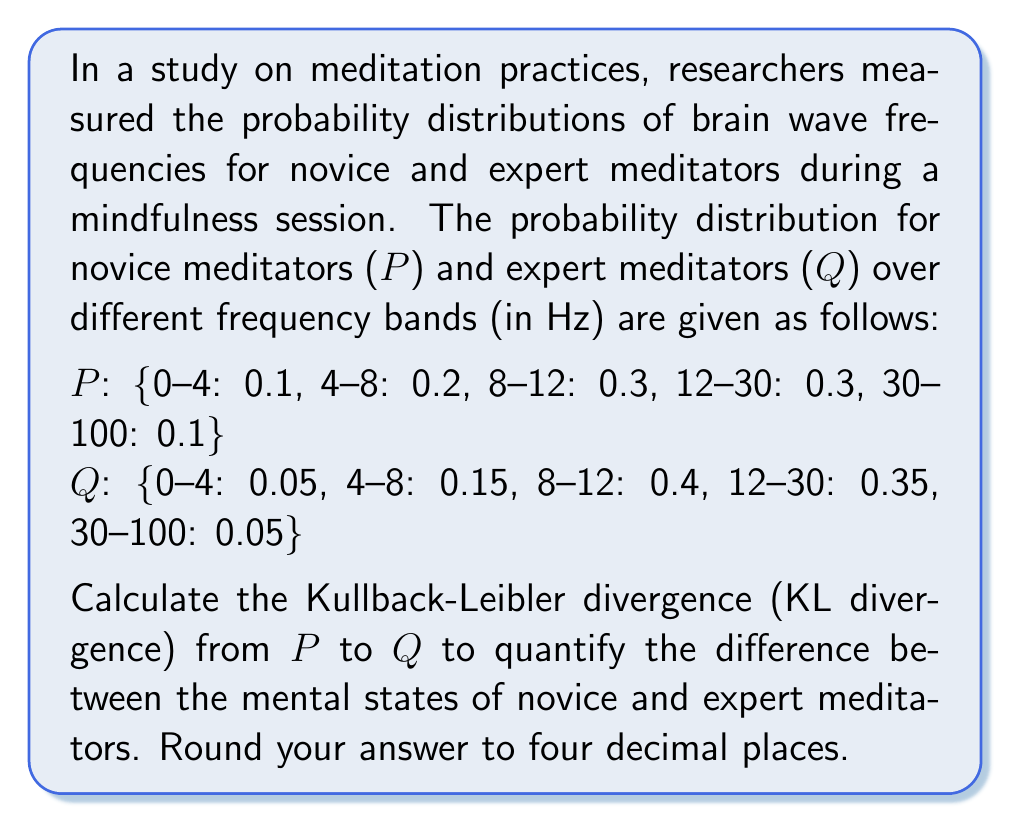Provide a solution to this math problem. To solve this problem, we'll use the Kullback-Leibler divergence formula:

$$ D_{KL}(P||Q) = \sum_{i} P(i) \log\left(\frac{P(i)}{Q(i)}\right) $$

Where P(i) and Q(i) are the probabilities for each frequency band for novice and expert meditators, respectively.

Let's calculate the KL divergence for each frequency band:

1. 0-4 Hz:
   $0.1 \log\left(\frac{0.1}{0.05}\right) = 0.1 \log(2) \approx 0.0693$

2. 4-8 Hz:
   $0.2 \log\left(\frac{0.2}{0.15}\right) \approx 0.0280$

3. 8-12 Hz:
   $0.3 \log\left(\frac{0.3}{0.4}\right) \approx -0.0406$

4. 12-30 Hz:
   $0.3 \log\left(\frac{0.3}{0.35}\right) \approx -0.0219$

5. 30-100 Hz:
   $0.1 \log\left(\frac{0.1}{0.05}\right) = 0.1 \log(2) \approx 0.0693$

Now, we sum up all these values:

$$ D_{KL}(P||Q) = 0.0693 + 0.0280 - 0.0406 - 0.0219 + 0.0693 = 0.1041 $$

Rounding to four decimal places, we get 0.1041.

This value quantifies the information lost when using the expert meditators' distribution (Q) to approximate the novice meditators' distribution (P). A higher value indicates a greater difference between the two distributions, suggesting more significant differences in mental states between novice and expert meditators.
Answer: 0.1041 